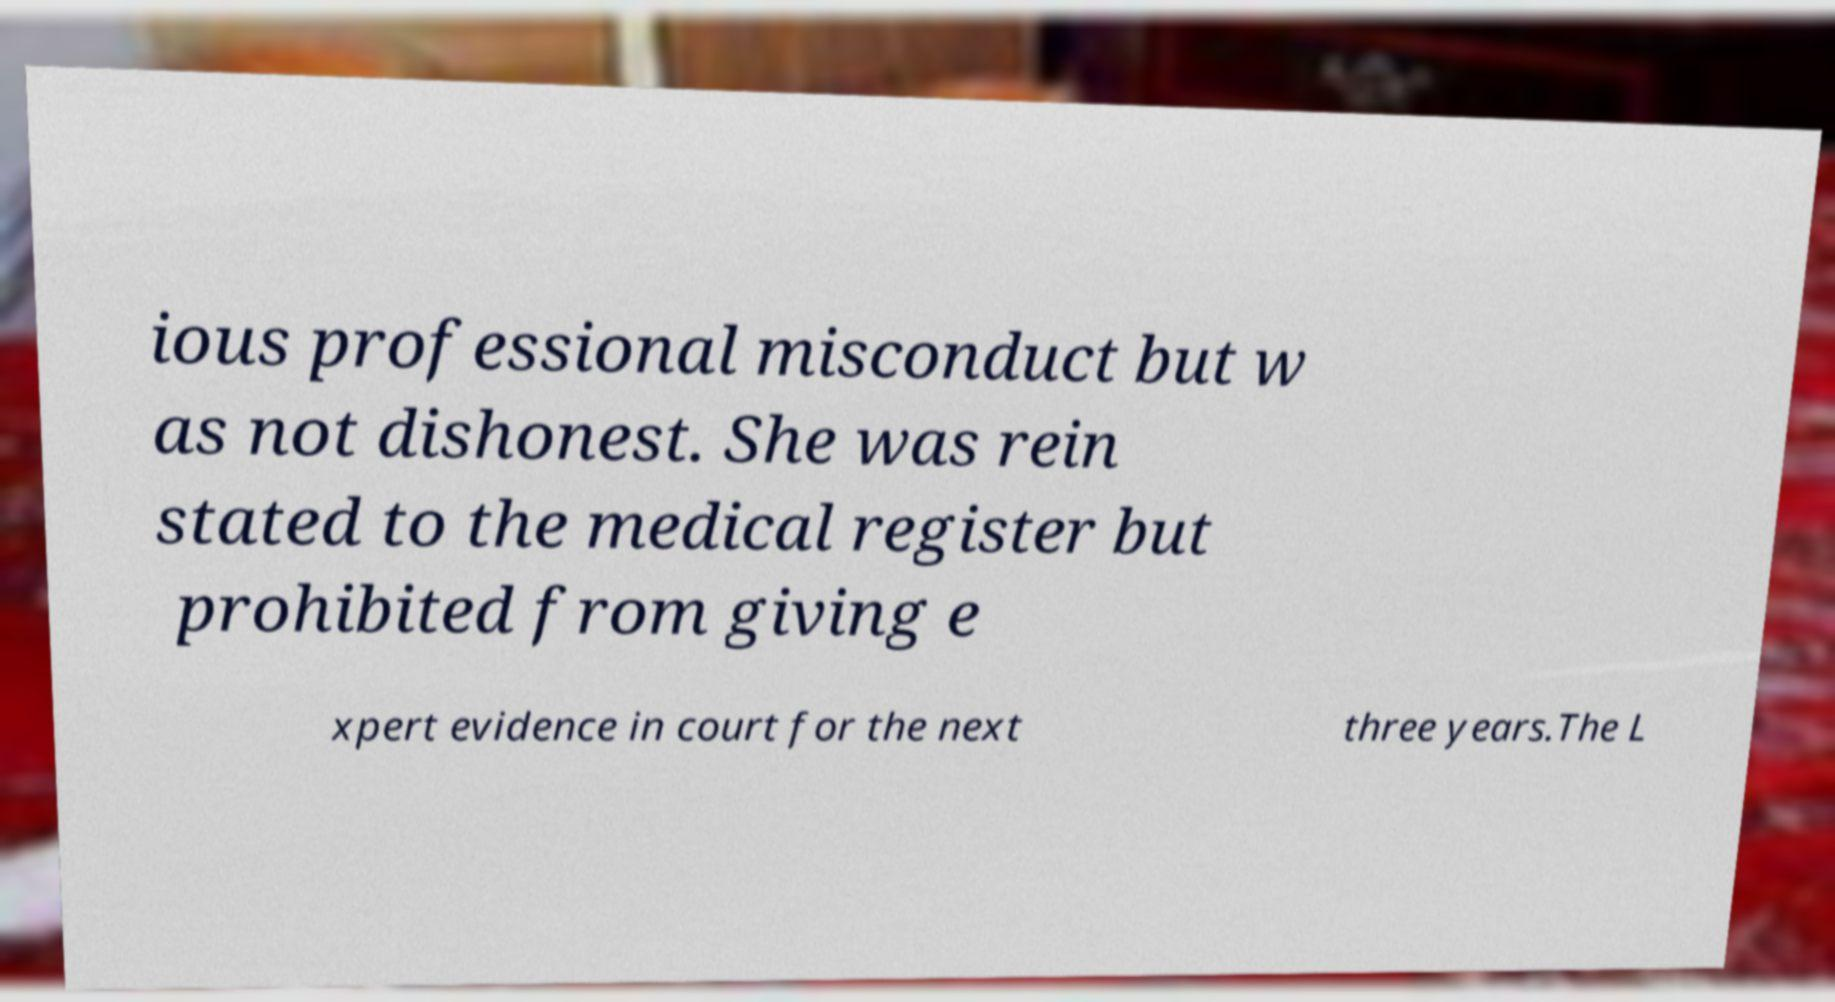Please identify and transcribe the text found in this image. ious professional misconduct but w as not dishonest. She was rein stated to the medical register but prohibited from giving e xpert evidence in court for the next three years.The L 